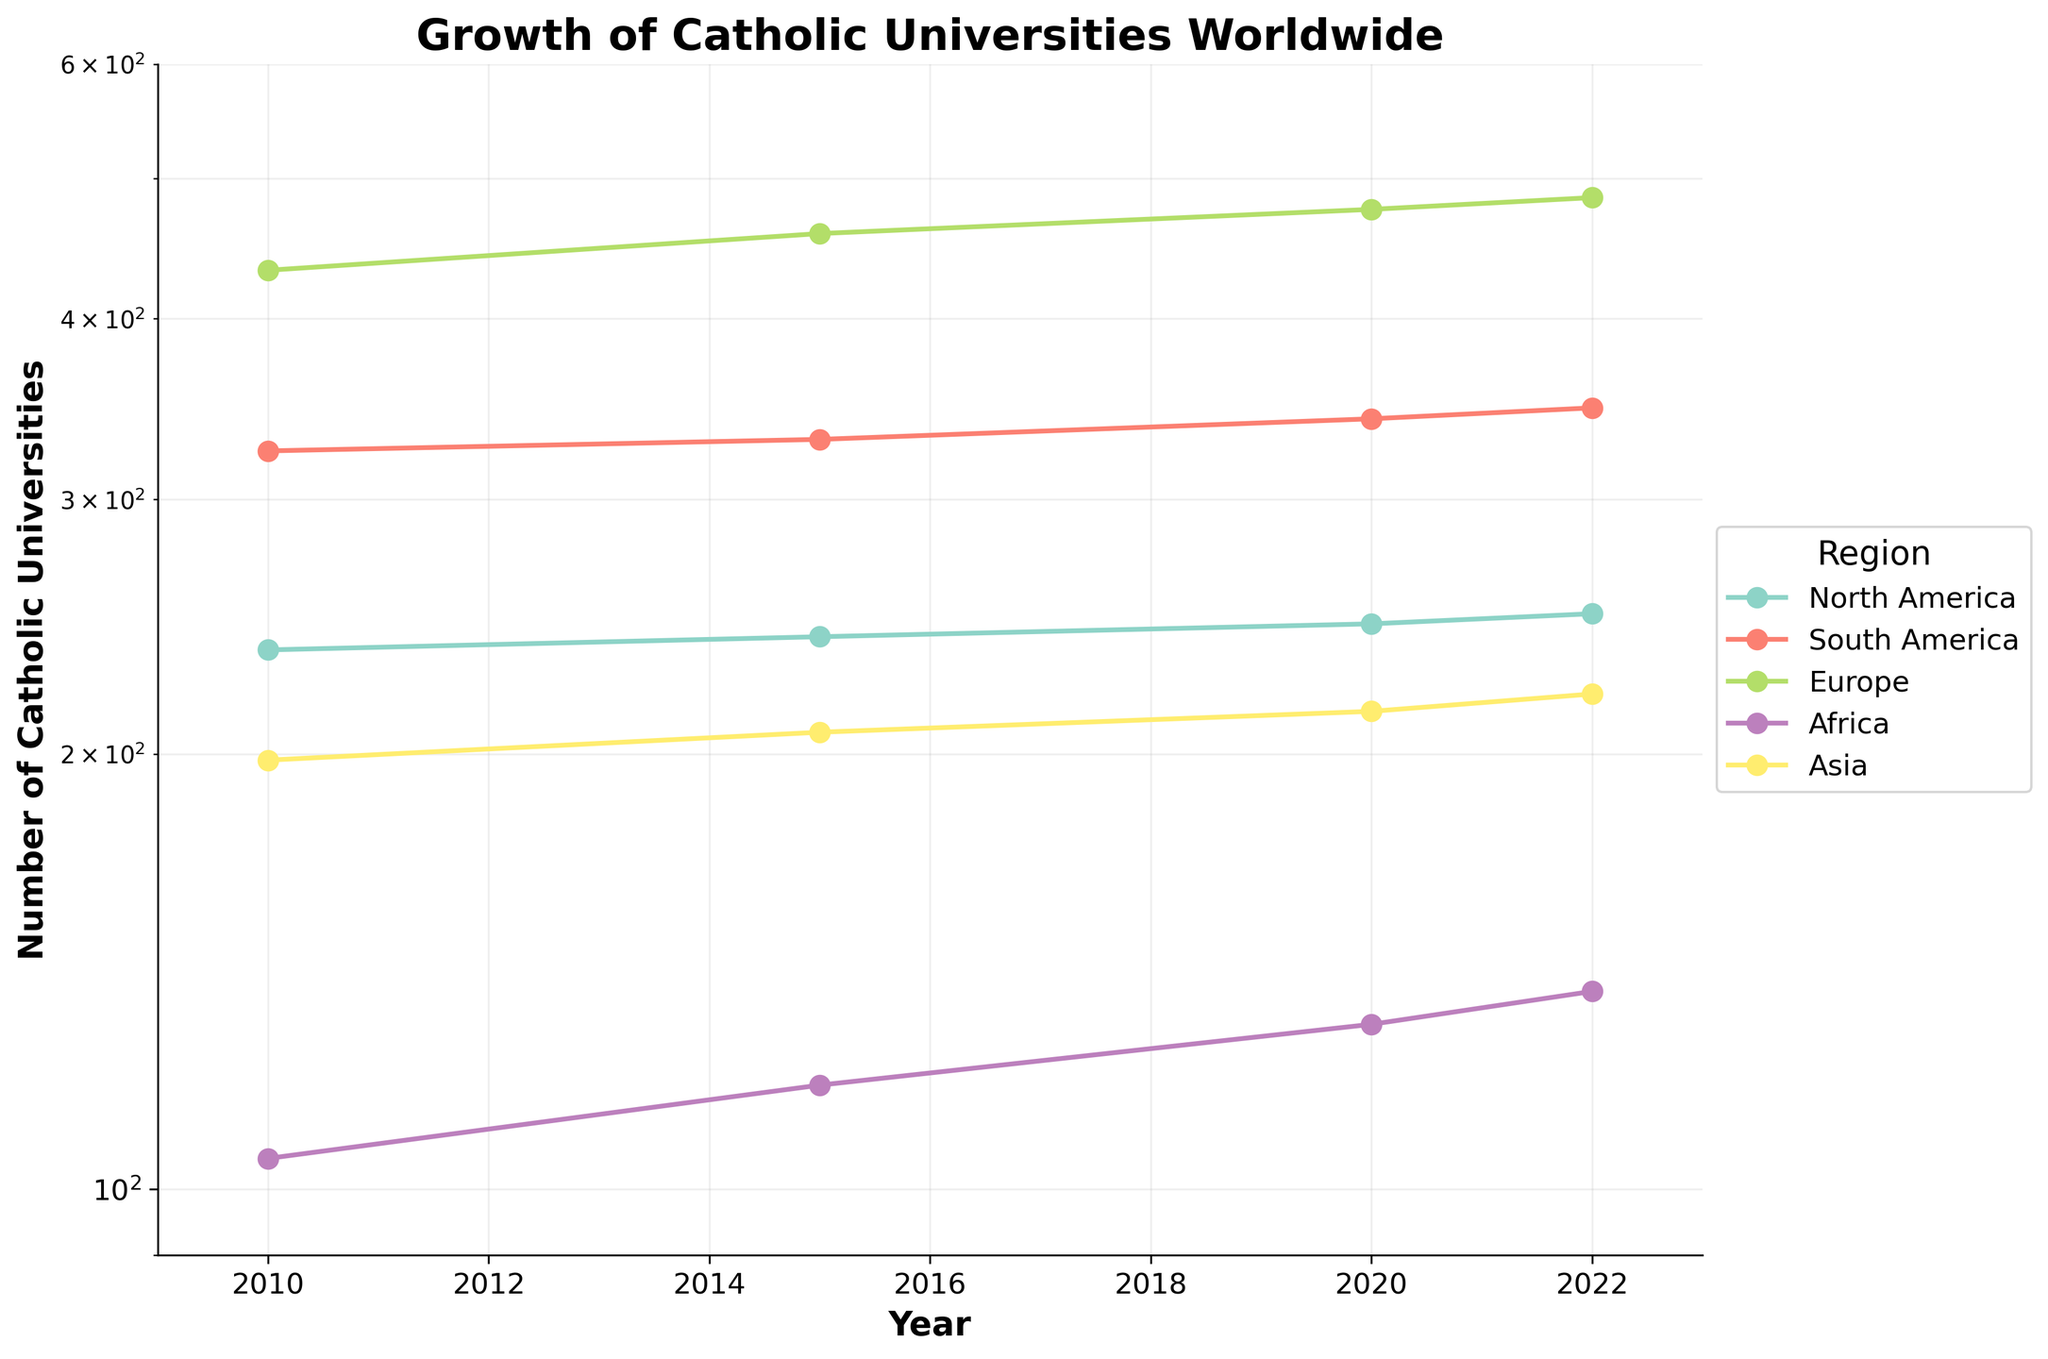What's the title of the figure? The title is displayed at the top of the figure and usually gives a brief explanation of what the plot represents. In this case, the title is "Growth of Catholic Universities Worldwide."
Answer: Growth of Catholic Universities Worldwide What's the y-axis label? The y-axis label is located on the vertical axis and explains what quantity is being measured. For this figure, it is "Number of Catholic Universities."
Answer: Number of Catholic Universities Which region had the highest number of universities in 2022? To find the region with the highest number of universities in 2022, look for the data point in 2022 that is the highest on the y-axis. By observing the plot, you can see that Europe has the highest number with 485 universities.
Answer: Europe Which two regions had a similar number of universities in 2010? To determine which two regions had a similar number of universities in 2010, compare the data points for that year across all regions. For 2010, North America (236) and Asia (198) appear to be somewhat close in number, but Asia is visually closer to Africa (105). Thus the closest are Asia and Africa with numbers significantly closer together than any other pair.
Answer: Asia and Africa How has the number of universities grown in North America from 2010 to 2022? To analyze the growth in North America, subtract the number of universities in 2010 from the number in 2022. In 2010, North America had 236 universities, and in 2022, it had 250. Thus, the growth is 250 - 236 = 14.
Answer: 14 Which region showed the largest growth in the number of universities between 2010 and 2022? By comparing the starting and ending values for each region, calculate the growth: 
South America: 347 - 324 = 23 
Europe: 485 - 432 = 53 
Africa: 137 - 105 = 32 
Asia: 220 - 198 = 22 
Europe shows the largest growth with 53 added universities.
Answer: Europe Which regions' growth of universities remained almost linear on this log scale plot? On a log scale plot, linear-looking growth indicates exponential growth in actual values. Asia and Europe appear to show relatively linear growth on the log scale plot, indicating steady and consistent growth rates.
Answer: Asia and Europe What is the range of the y-axis in this plot? The range can be determined by looking at the lowest and highest values shown on the y-axis. The plot's y-axis ranges from 90 to 600 as indicated on the figure.
Answer: 90 to 600 How many universities did Africa have in 2020? Locate the data point corresponding to the year 2020 for the Africa series. The number of universities is 130.
Answer: 130 